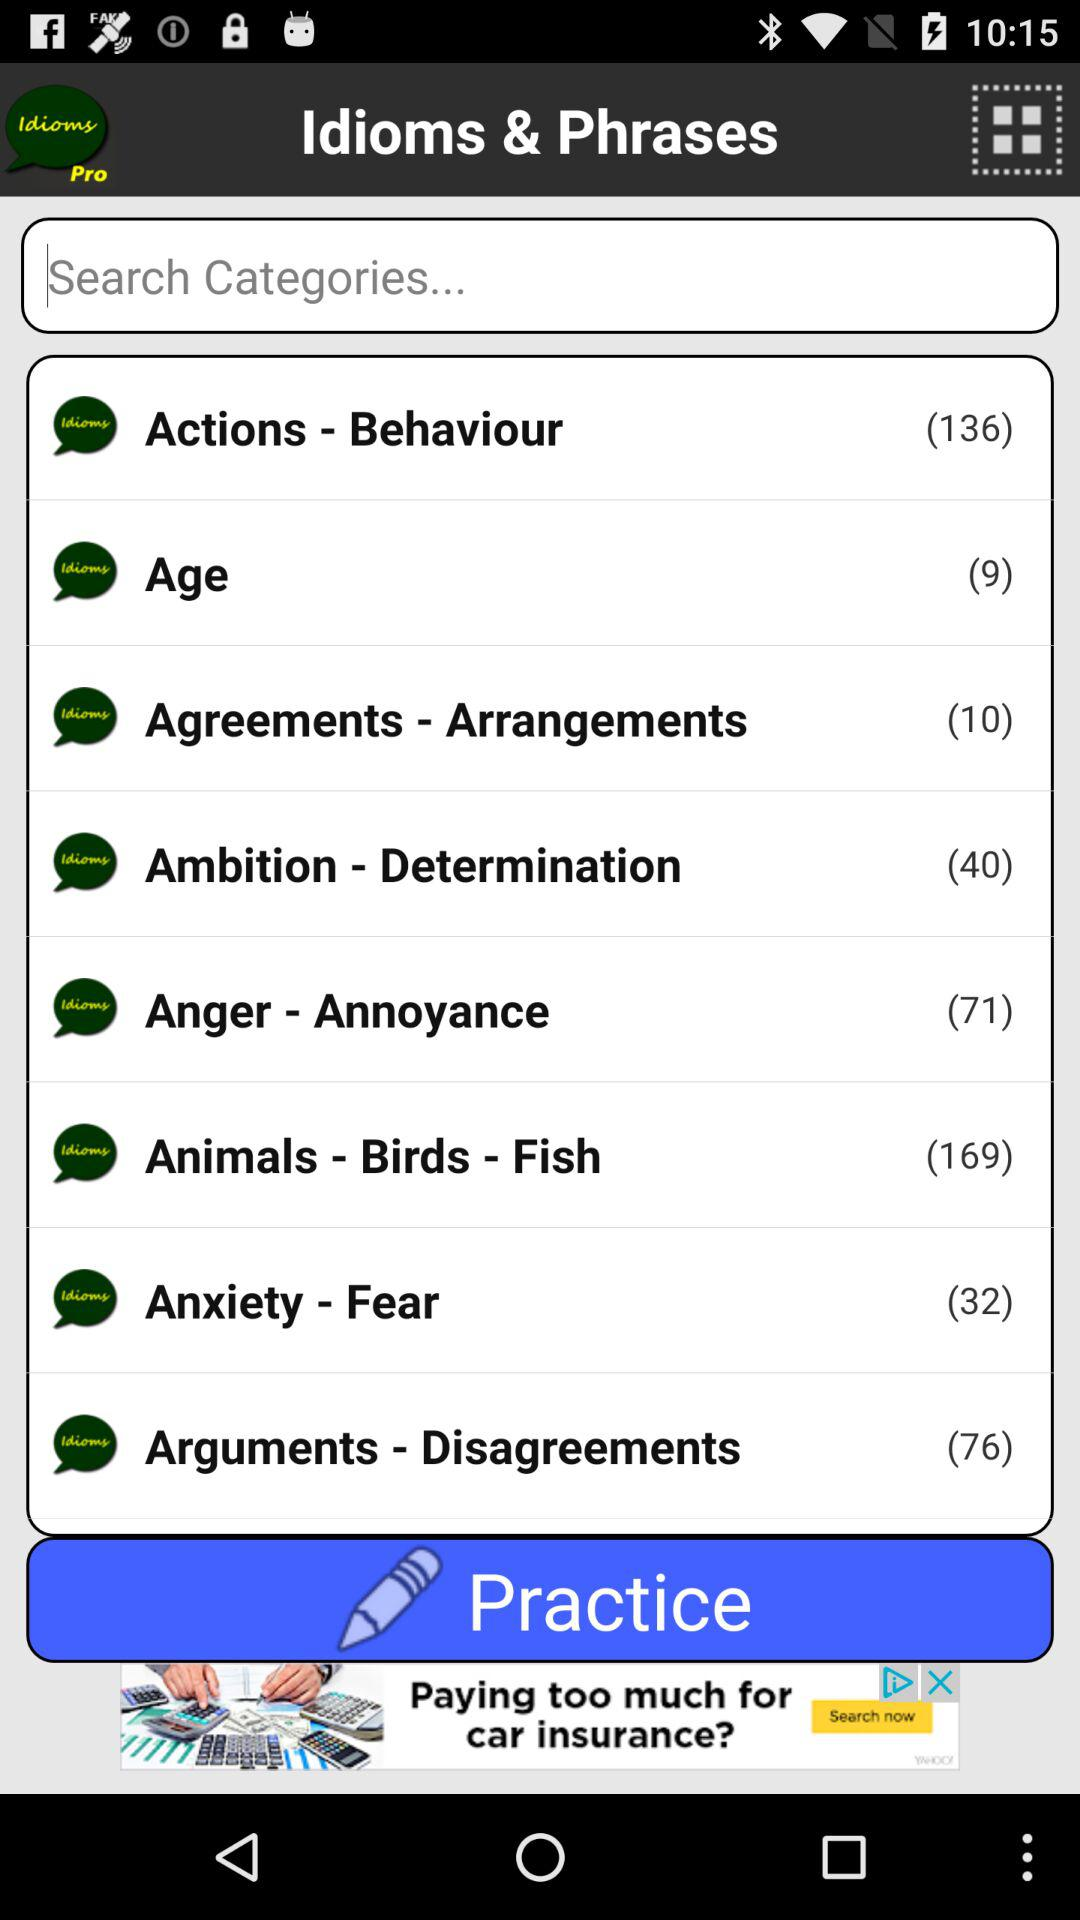Who is this application powered by?
When the provided information is insufficient, respond with <no answer>. <no answer> 